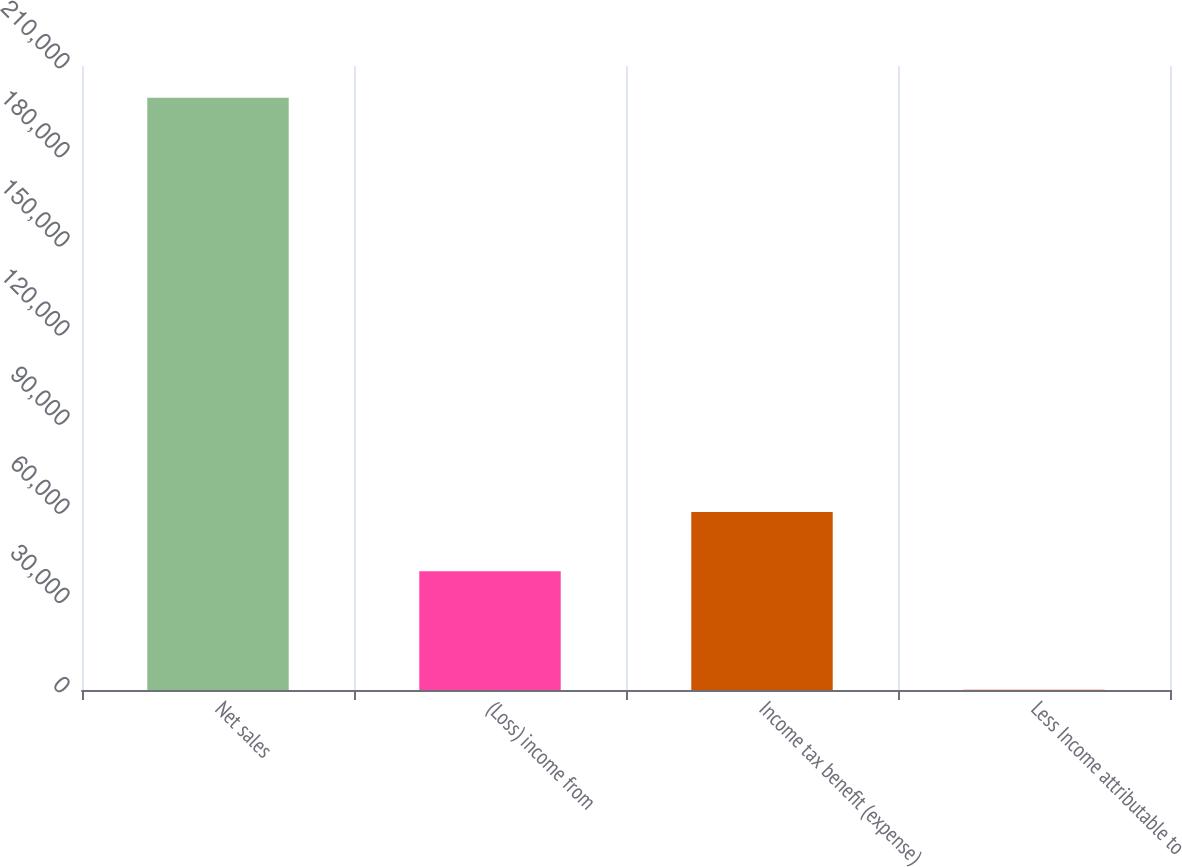Convert chart. <chart><loc_0><loc_0><loc_500><loc_500><bar_chart><fcel>Net sales<fcel>(Loss) income from<fcel>Income tax benefit (expense)<fcel>Less Income attributable to<nl><fcel>199356<fcel>39949.6<fcel>59875.4<fcel>98<nl></chart> 